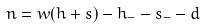<formula> <loc_0><loc_0><loc_500><loc_500>n = w ( h + s ) - h _ { - } - s _ { - } - d</formula> 